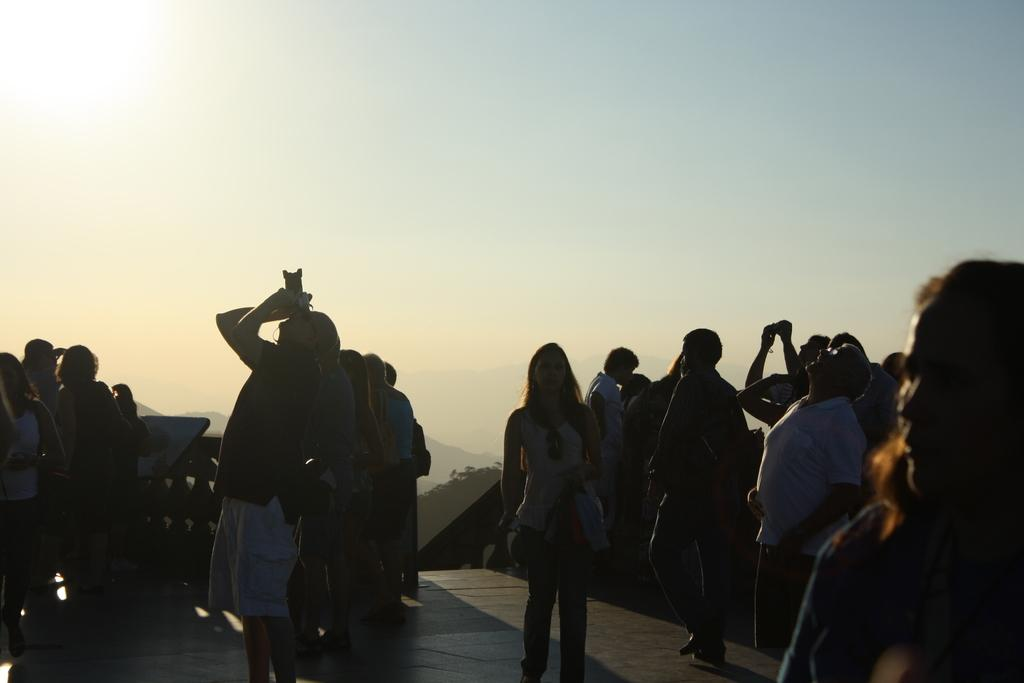How many people are in the image? There is a group of people in the image, but the exact number is not specified. What are the people doing in the image? The people are gathered at some place, but their specific activity is not mentioned. What can be seen in the background of the image? There are mountains visible in the background of the image. What type of popcorn is being served at the event in the image? There is no mention of popcorn or an event in the image, so it cannot be determined if popcorn is being served. 